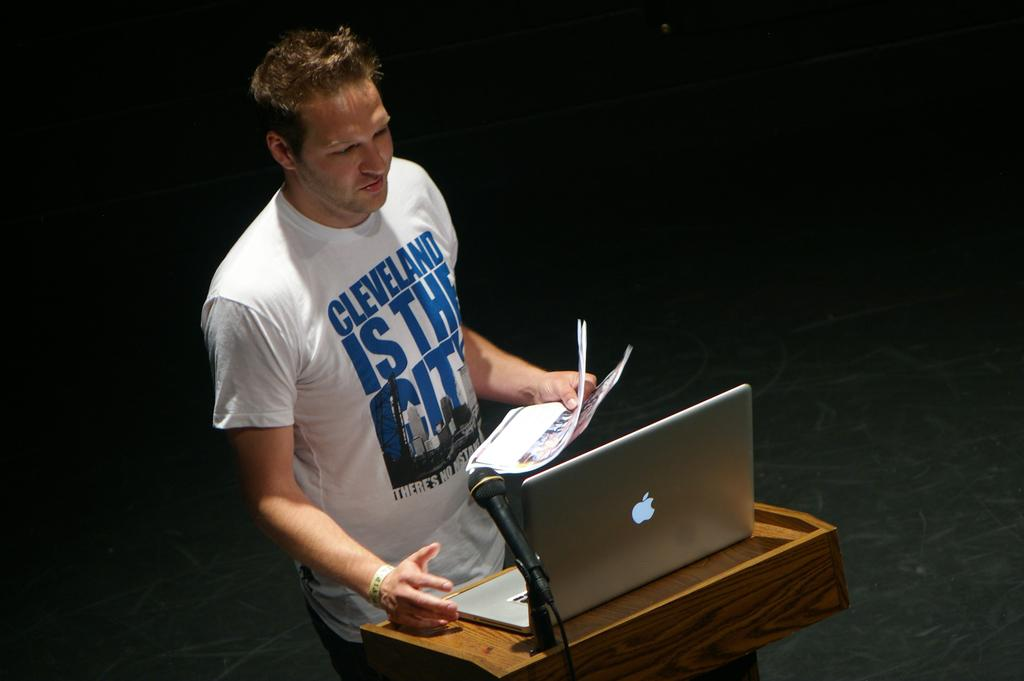<image>
Offer a succinct explanation of the picture presented. the name Cleveland is on a person's shirt 